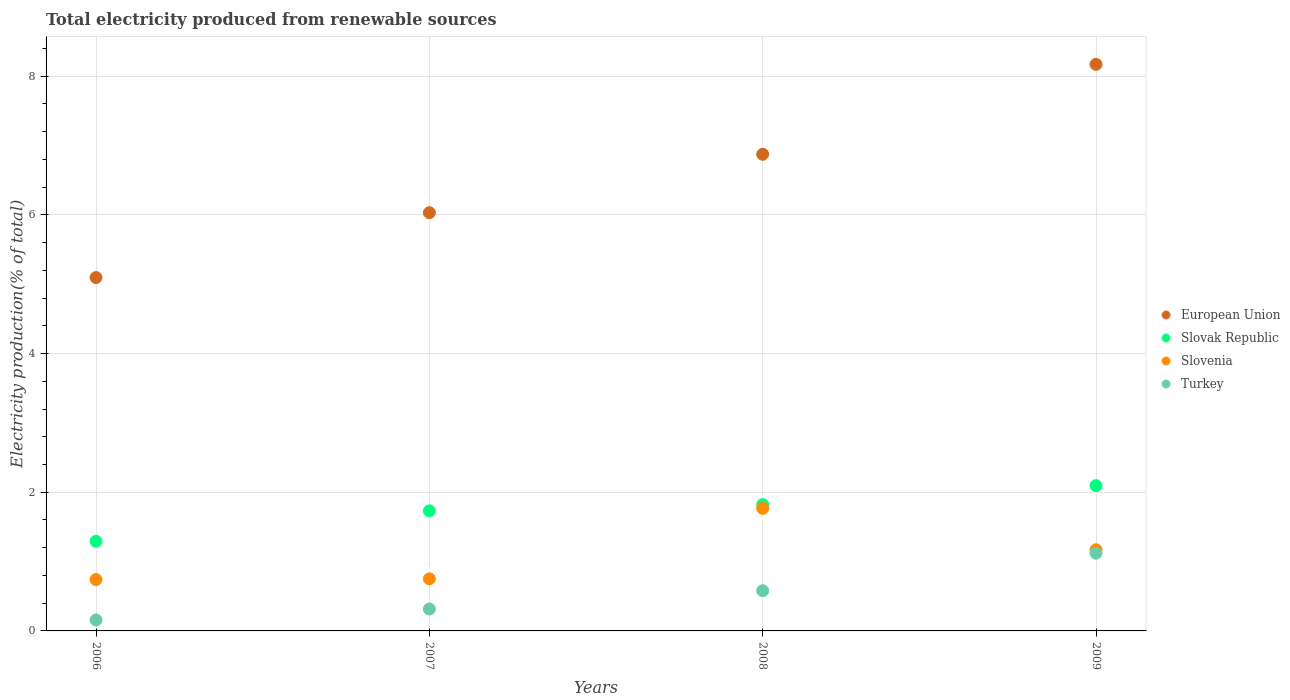How many different coloured dotlines are there?
Your answer should be compact. 4. Is the number of dotlines equal to the number of legend labels?
Keep it short and to the point. Yes. What is the total electricity produced in Slovenia in 2007?
Provide a succinct answer. 0.75. Across all years, what is the maximum total electricity produced in Slovak Republic?
Provide a short and direct response. 2.09. Across all years, what is the minimum total electricity produced in Slovak Republic?
Ensure brevity in your answer.  1.29. What is the total total electricity produced in Slovenia in the graph?
Your response must be concise. 4.43. What is the difference between the total electricity produced in European Union in 2007 and that in 2009?
Your response must be concise. -2.14. What is the difference between the total electricity produced in European Union in 2006 and the total electricity produced in Slovak Republic in 2009?
Offer a terse response. 3. What is the average total electricity produced in Slovak Republic per year?
Your response must be concise. 1.74. In the year 2008, what is the difference between the total electricity produced in Slovenia and total electricity produced in Slovak Republic?
Ensure brevity in your answer.  -0.05. What is the ratio of the total electricity produced in Turkey in 2006 to that in 2008?
Make the answer very short. 0.27. What is the difference between the highest and the second highest total electricity produced in Slovenia?
Make the answer very short. 0.6. What is the difference between the highest and the lowest total electricity produced in Turkey?
Offer a very short reply. 0.96. In how many years, is the total electricity produced in Slovak Republic greater than the average total electricity produced in Slovak Republic taken over all years?
Make the answer very short. 2. Is it the case that in every year, the sum of the total electricity produced in Turkey and total electricity produced in Slovenia  is greater than the sum of total electricity produced in Slovak Republic and total electricity produced in European Union?
Ensure brevity in your answer.  No. Is the total electricity produced in Slovak Republic strictly less than the total electricity produced in European Union over the years?
Your response must be concise. Yes. How many years are there in the graph?
Make the answer very short. 4. What is the difference between two consecutive major ticks on the Y-axis?
Give a very brief answer. 2. Are the values on the major ticks of Y-axis written in scientific E-notation?
Your answer should be compact. No. Where does the legend appear in the graph?
Your answer should be compact. Center right. How are the legend labels stacked?
Provide a succinct answer. Vertical. What is the title of the graph?
Offer a very short reply. Total electricity produced from renewable sources. What is the label or title of the Y-axis?
Your response must be concise. Electricity production(% of total). What is the Electricity production(% of total) in European Union in 2006?
Make the answer very short. 5.1. What is the Electricity production(% of total) in Slovak Republic in 2006?
Provide a succinct answer. 1.29. What is the Electricity production(% of total) of Slovenia in 2006?
Offer a terse response. 0.74. What is the Electricity production(% of total) in Turkey in 2006?
Offer a very short reply. 0.16. What is the Electricity production(% of total) in European Union in 2007?
Provide a short and direct response. 6.03. What is the Electricity production(% of total) of Slovak Republic in 2007?
Give a very brief answer. 1.73. What is the Electricity production(% of total) of Slovenia in 2007?
Keep it short and to the point. 0.75. What is the Electricity production(% of total) of Turkey in 2007?
Keep it short and to the point. 0.32. What is the Electricity production(% of total) of European Union in 2008?
Offer a terse response. 6.87. What is the Electricity production(% of total) in Slovak Republic in 2008?
Your answer should be compact. 1.82. What is the Electricity production(% of total) of Slovenia in 2008?
Give a very brief answer. 1.77. What is the Electricity production(% of total) in Turkey in 2008?
Provide a succinct answer. 0.58. What is the Electricity production(% of total) of European Union in 2009?
Ensure brevity in your answer.  8.17. What is the Electricity production(% of total) of Slovak Republic in 2009?
Your answer should be very brief. 2.09. What is the Electricity production(% of total) of Slovenia in 2009?
Offer a terse response. 1.17. What is the Electricity production(% of total) in Turkey in 2009?
Your answer should be very brief. 1.12. Across all years, what is the maximum Electricity production(% of total) of European Union?
Offer a very short reply. 8.17. Across all years, what is the maximum Electricity production(% of total) in Slovak Republic?
Provide a short and direct response. 2.09. Across all years, what is the maximum Electricity production(% of total) of Slovenia?
Provide a short and direct response. 1.77. Across all years, what is the maximum Electricity production(% of total) of Turkey?
Ensure brevity in your answer.  1.12. Across all years, what is the minimum Electricity production(% of total) in European Union?
Provide a succinct answer. 5.1. Across all years, what is the minimum Electricity production(% of total) in Slovak Republic?
Your answer should be compact. 1.29. Across all years, what is the minimum Electricity production(% of total) of Slovenia?
Make the answer very short. 0.74. Across all years, what is the minimum Electricity production(% of total) in Turkey?
Your answer should be compact. 0.16. What is the total Electricity production(% of total) in European Union in the graph?
Make the answer very short. 26.17. What is the total Electricity production(% of total) of Slovak Republic in the graph?
Give a very brief answer. 6.94. What is the total Electricity production(% of total) of Slovenia in the graph?
Your response must be concise. 4.43. What is the total Electricity production(% of total) of Turkey in the graph?
Offer a very short reply. 2.17. What is the difference between the Electricity production(% of total) of European Union in 2006 and that in 2007?
Give a very brief answer. -0.94. What is the difference between the Electricity production(% of total) in Slovak Republic in 2006 and that in 2007?
Keep it short and to the point. -0.44. What is the difference between the Electricity production(% of total) of Slovenia in 2006 and that in 2007?
Your answer should be very brief. -0.01. What is the difference between the Electricity production(% of total) of Turkey in 2006 and that in 2007?
Offer a very short reply. -0.16. What is the difference between the Electricity production(% of total) of European Union in 2006 and that in 2008?
Your answer should be compact. -1.78. What is the difference between the Electricity production(% of total) of Slovak Republic in 2006 and that in 2008?
Your answer should be compact. -0.53. What is the difference between the Electricity production(% of total) in Slovenia in 2006 and that in 2008?
Offer a terse response. -1.03. What is the difference between the Electricity production(% of total) of Turkey in 2006 and that in 2008?
Your answer should be compact. -0.42. What is the difference between the Electricity production(% of total) in European Union in 2006 and that in 2009?
Your answer should be very brief. -3.07. What is the difference between the Electricity production(% of total) of Slovak Republic in 2006 and that in 2009?
Provide a short and direct response. -0.8. What is the difference between the Electricity production(% of total) of Slovenia in 2006 and that in 2009?
Keep it short and to the point. -0.43. What is the difference between the Electricity production(% of total) of Turkey in 2006 and that in 2009?
Provide a short and direct response. -0.96. What is the difference between the Electricity production(% of total) of European Union in 2007 and that in 2008?
Provide a short and direct response. -0.84. What is the difference between the Electricity production(% of total) of Slovak Republic in 2007 and that in 2008?
Your answer should be very brief. -0.09. What is the difference between the Electricity production(% of total) of Slovenia in 2007 and that in 2008?
Your answer should be very brief. -1.02. What is the difference between the Electricity production(% of total) in Turkey in 2007 and that in 2008?
Offer a very short reply. -0.26. What is the difference between the Electricity production(% of total) of European Union in 2007 and that in 2009?
Offer a very short reply. -2.14. What is the difference between the Electricity production(% of total) of Slovak Republic in 2007 and that in 2009?
Give a very brief answer. -0.36. What is the difference between the Electricity production(% of total) of Slovenia in 2007 and that in 2009?
Your answer should be very brief. -0.42. What is the difference between the Electricity production(% of total) of Turkey in 2007 and that in 2009?
Your response must be concise. -0.8. What is the difference between the Electricity production(% of total) of European Union in 2008 and that in 2009?
Your answer should be compact. -1.3. What is the difference between the Electricity production(% of total) in Slovak Republic in 2008 and that in 2009?
Your response must be concise. -0.27. What is the difference between the Electricity production(% of total) in Slovenia in 2008 and that in 2009?
Provide a short and direct response. 0.6. What is the difference between the Electricity production(% of total) of Turkey in 2008 and that in 2009?
Provide a succinct answer. -0.54. What is the difference between the Electricity production(% of total) of European Union in 2006 and the Electricity production(% of total) of Slovak Republic in 2007?
Keep it short and to the point. 3.36. What is the difference between the Electricity production(% of total) in European Union in 2006 and the Electricity production(% of total) in Slovenia in 2007?
Keep it short and to the point. 4.35. What is the difference between the Electricity production(% of total) of European Union in 2006 and the Electricity production(% of total) of Turkey in 2007?
Offer a terse response. 4.78. What is the difference between the Electricity production(% of total) of Slovak Republic in 2006 and the Electricity production(% of total) of Slovenia in 2007?
Provide a succinct answer. 0.54. What is the difference between the Electricity production(% of total) in Slovak Republic in 2006 and the Electricity production(% of total) in Turkey in 2007?
Provide a succinct answer. 0.98. What is the difference between the Electricity production(% of total) in Slovenia in 2006 and the Electricity production(% of total) in Turkey in 2007?
Your response must be concise. 0.42. What is the difference between the Electricity production(% of total) in European Union in 2006 and the Electricity production(% of total) in Slovak Republic in 2008?
Give a very brief answer. 3.27. What is the difference between the Electricity production(% of total) in European Union in 2006 and the Electricity production(% of total) in Slovenia in 2008?
Offer a very short reply. 3.33. What is the difference between the Electricity production(% of total) in European Union in 2006 and the Electricity production(% of total) in Turkey in 2008?
Your answer should be compact. 4.52. What is the difference between the Electricity production(% of total) of Slovak Republic in 2006 and the Electricity production(% of total) of Slovenia in 2008?
Make the answer very short. -0.48. What is the difference between the Electricity production(% of total) in Slovak Republic in 2006 and the Electricity production(% of total) in Turkey in 2008?
Provide a succinct answer. 0.71. What is the difference between the Electricity production(% of total) in Slovenia in 2006 and the Electricity production(% of total) in Turkey in 2008?
Offer a very short reply. 0.16. What is the difference between the Electricity production(% of total) in European Union in 2006 and the Electricity production(% of total) in Slovak Republic in 2009?
Give a very brief answer. 3. What is the difference between the Electricity production(% of total) of European Union in 2006 and the Electricity production(% of total) of Slovenia in 2009?
Your answer should be very brief. 3.93. What is the difference between the Electricity production(% of total) in European Union in 2006 and the Electricity production(% of total) in Turkey in 2009?
Offer a very short reply. 3.98. What is the difference between the Electricity production(% of total) of Slovak Republic in 2006 and the Electricity production(% of total) of Slovenia in 2009?
Your response must be concise. 0.12. What is the difference between the Electricity production(% of total) of Slovak Republic in 2006 and the Electricity production(% of total) of Turkey in 2009?
Your answer should be very brief. 0.17. What is the difference between the Electricity production(% of total) of Slovenia in 2006 and the Electricity production(% of total) of Turkey in 2009?
Keep it short and to the point. -0.38. What is the difference between the Electricity production(% of total) of European Union in 2007 and the Electricity production(% of total) of Slovak Republic in 2008?
Ensure brevity in your answer.  4.21. What is the difference between the Electricity production(% of total) in European Union in 2007 and the Electricity production(% of total) in Slovenia in 2008?
Provide a succinct answer. 4.26. What is the difference between the Electricity production(% of total) in European Union in 2007 and the Electricity production(% of total) in Turkey in 2008?
Make the answer very short. 5.45. What is the difference between the Electricity production(% of total) of Slovak Republic in 2007 and the Electricity production(% of total) of Slovenia in 2008?
Offer a very short reply. -0.04. What is the difference between the Electricity production(% of total) in Slovak Republic in 2007 and the Electricity production(% of total) in Turkey in 2008?
Ensure brevity in your answer.  1.15. What is the difference between the Electricity production(% of total) of Slovenia in 2007 and the Electricity production(% of total) of Turkey in 2008?
Keep it short and to the point. 0.17. What is the difference between the Electricity production(% of total) of European Union in 2007 and the Electricity production(% of total) of Slovak Republic in 2009?
Keep it short and to the point. 3.94. What is the difference between the Electricity production(% of total) of European Union in 2007 and the Electricity production(% of total) of Slovenia in 2009?
Provide a succinct answer. 4.86. What is the difference between the Electricity production(% of total) in European Union in 2007 and the Electricity production(% of total) in Turkey in 2009?
Make the answer very short. 4.91. What is the difference between the Electricity production(% of total) of Slovak Republic in 2007 and the Electricity production(% of total) of Slovenia in 2009?
Offer a very short reply. 0.56. What is the difference between the Electricity production(% of total) in Slovak Republic in 2007 and the Electricity production(% of total) in Turkey in 2009?
Offer a very short reply. 0.61. What is the difference between the Electricity production(% of total) of Slovenia in 2007 and the Electricity production(% of total) of Turkey in 2009?
Ensure brevity in your answer.  -0.37. What is the difference between the Electricity production(% of total) of European Union in 2008 and the Electricity production(% of total) of Slovak Republic in 2009?
Provide a succinct answer. 4.78. What is the difference between the Electricity production(% of total) in European Union in 2008 and the Electricity production(% of total) in Slovenia in 2009?
Keep it short and to the point. 5.7. What is the difference between the Electricity production(% of total) of European Union in 2008 and the Electricity production(% of total) of Turkey in 2009?
Offer a terse response. 5.75. What is the difference between the Electricity production(% of total) in Slovak Republic in 2008 and the Electricity production(% of total) in Slovenia in 2009?
Keep it short and to the point. 0.65. What is the difference between the Electricity production(% of total) in Slovak Republic in 2008 and the Electricity production(% of total) in Turkey in 2009?
Your answer should be very brief. 0.7. What is the difference between the Electricity production(% of total) in Slovenia in 2008 and the Electricity production(% of total) in Turkey in 2009?
Keep it short and to the point. 0.65. What is the average Electricity production(% of total) of European Union per year?
Your response must be concise. 6.54. What is the average Electricity production(% of total) of Slovak Republic per year?
Offer a very short reply. 1.74. What is the average Electricity production(% of total) of Slovenia per year?
Provide a short and direct response. 1.11. What is the average Electricity production(% of total) of Turkey per year?
Ensure brevity in your answer.  0.54. In the year 2006, what is the difference between the Electricity production(% of total) of European Union and Electricity production(% of total) of Slovak Republic?
Provide a short and direct response. 3.8. In the year 2006, what is the difference between the Electricity production(% of total) of European Union and Electricity production(% of total) of Slovenia?
Your answer should be very brief. 4.36. In the year 2006, what is the difference between the Electricity production(% of total) in European Union and Electricity production(% of total) in Turkey?
Your response must be concise. 4.94. In the year 2006, what is the difference between the Electricity production(% of total) of Slovak Republic and Electricity production(% of total) of Slovenia?
Your response must be concise. 0.55. In the year 2006, what is the difference between the Electricity production(% of total) in Slovak Republic and Electricity production(% of total) in Turkey?
Ensure brevity in your answer.  1.14. In the year 2006, what is the difference between the Electricity production(% of total) of Slovenia and Electricity production(% of total) of Turkey?
Ensure brevity in your answer.  0.58. In the year 2007, what is the difference between the Electricity production(% of total) of European Union and Electricity production(% of total) of Slovak Republic?
Your answer should be very brief. 4.3. In the year 2007, what is the difference between the Electricity production(% of total) in European Union and Electricity production(% of total) in Slovenia?
Your response must be concise. 5.28. In the year 2007, what is the difference between the Electricity production(% of total) in European Union and Electricity production(% of total) in Turkey?
Keep it short and to the point. 5.72. In the year 2007, what is the difference between the Electricity production(% of total) in Slovak Republic and Electricity production(% of total) in Slovenia?
Your answer should be very brief. 0.98. In the year 2007, what is the difference between the Electricity production(% of total) in Slovak Republic and Electricity production(% of total) in Turkey?
Offer a very short reply. 1.42. In the year 2007, what is the difference between the Electricity production(% of total) of Slovenia and Electricity production(% of total) of Turkey?
Your response must be concise. 0.43. In the year 2008, what is the difference between the Electricity production(% of total) of European Union and Electricity production(% of total) of Slovak Republic?
Provide a short and direct response. 5.05. In the year 2008, what is the difference between the Electricity production(% of total) of European Union and Electricity production(% of total) of Slovenia?
Ensure brevity in your answer.  5.11. In the year 2008, what is the difference between the Electricity production(% of total) in European Union and Electricity production(% of total) in Turkey?
Offer a very short reply. 6.29. In the year 2008, what is the difference between the Electricity production(% of total) of Slovak Republic and Electricity production(% of total) of Slovenia?
Provide a succinct answer. 0.05. In the year 2008, what is the difference between the Electricity production(% of total) of Slovak Republic and Electricity production(% of total) of Turkey?
Your answer should be very brief. 1.24. In the year 2008, what is the difference between the Electricity production(% of total) of Slovenia and Electricity production(% of total) of Turkey?
Give a very brief answer. 1.19. In the year 2009, what is the difference between the Electricity production(% of total) of European Union and Electricity production(% of total) of Slovak Republic?
Your answer should be compact. 6.08. In the year 2009, what is the difference between the Electricity production(% of total) in European Union and Electricity production(% of total) in Slovenia?
Keep it short and to the point. 7. In the year 2009, what is the difference between the Electricity production(% of total) in European Union and Electricity production(% of total) in Turkey?
Make the answer very short. 7.05. In the year 2009, what is the difference between the Electricity production(% of total) in Slovak Republic and Electricity production(% of total) in Slovenia?
Make the answer very short. 0.92. In the year 2009, what is the difference between the Electricity production(% of total) in Slovak Republic and Electricity production(% of total) in Turkey?
Make the answer very short. 0.97. In the year 2009, what is the difference between the Electricity production(% of total) in Slovenia and Electricity production(% of total) in Turkey?
Keep it short and to the point. 0.05. What is the ratio of the Electricity production(% of total) of European Union in 2006 to that in 2007?
Provide a succinct answer. 0.84. What is the ratio of the Electricity production(% of total) in Slovak Republic in 2006 to that in 2007?
Keep it short and to the point. 0.75. What is the ratio of the Electricity production(% of total) in Slovenia in 2006 to that in 2007?
Your answer should be very brief. 0.99. What is the ratio of the Electricity production(% of total) in Turkey in 2006 to that in 2007?
Give a very brief answer. 0.5. What is the ratio of the Electricity production(% of total) of European Union in 2006 to that in 2008?
Provide a succinct answer. 0.74. What is the ratio of the Electricity production(% of total) in Slovak Republic in 2006 to that in 2008?
Provide a short and direct response. 0.71. What is the ratio of the Electricity production(% of total) of Slovenia in 2006 to that in 2008?
Offer a very short reply. 0.42. What is the ratio of the Electricity production(% of total) of Turkey in 2006 to that in 2008?
Offer a terse response. 0.27. What is the ratio of the Electricity production(% of total) of European Union in 2006 to that in 2009?
Make the answer very short. 0.62. What is the ratio of the Electricity production(% of total) of Slovak Republic in 2006 to that in 2009?
Your answer should be compact. 0.62. What is the ratio of the Electricity production(% of total) of Slovenia in 2006 to that in 2009?
Make the answer very short. 0.63. What is the ratio of the Electricity production(% of total) in Turkey in 2006 to that in 2009?
Provide a short and direct response. 0.14. What is the ratio of the Electricity production(% of total) of European Union in 2007 to that in 2008?
Your response must be concise. 0.88. What is the ratio of the Electricity production(% of total) in Slovak Republic in 2007 to that in 2008?
Your response must be concise. 0.95. What is the ratio of the Electricity production(% of total) in Slovenia in 2007 to that in 2008?
Offer a very short reply. 0.42. What is the ratio of the Electricity production(% of total) in Turkey in 2007 to that in 2008?
Your answer should be compact. 0.55. What is the ratio of the Electricity production(% of total) in European Union in 2007 to that in 2009?
Give a very brief answer. 0.74. What is the ratio of the Electricity production(% of total) of Slovak Republic in 2007 to that in 2009?
Your answer should be very brief. 0.83. What is the ratio of the Electricity production(% of total) of Slovenia in 2007 to that in 2009?
Provide a succinct answer. 0.64. What is the ratio of the Electricity production(% of total) in Turkey in 2007 to that in 2009?
Provide a succinct answer. 0.28. What is the ratio of the Electricity production(% of total) of European Union in 2008 to that in 2009?
Give a very brief answer. 0.84. What is the ratio of the Electricity production(% of total) of Slovak Republic in 2008 to that in 2009?
Provide a succinct answer. 0.87. What is the ratio of the Electricity production(% of total) in Slovenia in 2008 to that in 2009?
Offer a very short reply. 1.51. What is the ratio of the Electricity production(% of total) of Turkey in 2008 to that in 2009?
Provide a succinct answer. 0.52. What is the difference between the highest and the second highest Electricity production(% of total) in European Union?
Provide a short and direct response. 1.3. What is the difference between the highest and the second highest Electricity production(% of total) in Slovak Republic?
Make the answer very short. 0.27. What is the difference between the highest and the second highest Electricity production(% of total) of Slovenia?
Your response must be concise. 0.6. What is the difference between the highest and the second highest Electricity production(% of total) of Turkey?
Provide a succinct answer. 0.54. What is the difference between the highest and the lowest Electricity production(% of total) in European Union?
Offer a very short reply. 3.07. What is the difference between the highest and the lowest Electricity production(% of total) in Slovak Republic?
Make the answer very short. 0.8. What is the difference between the highest and the lowest Electricity production(% of total) of Slovenia?
Offer a very short reply. 1.03. What is the difference between the highest and the lowest Electricity production(% of total) of Turkey?
Your answer should be very brief. 0.96. 